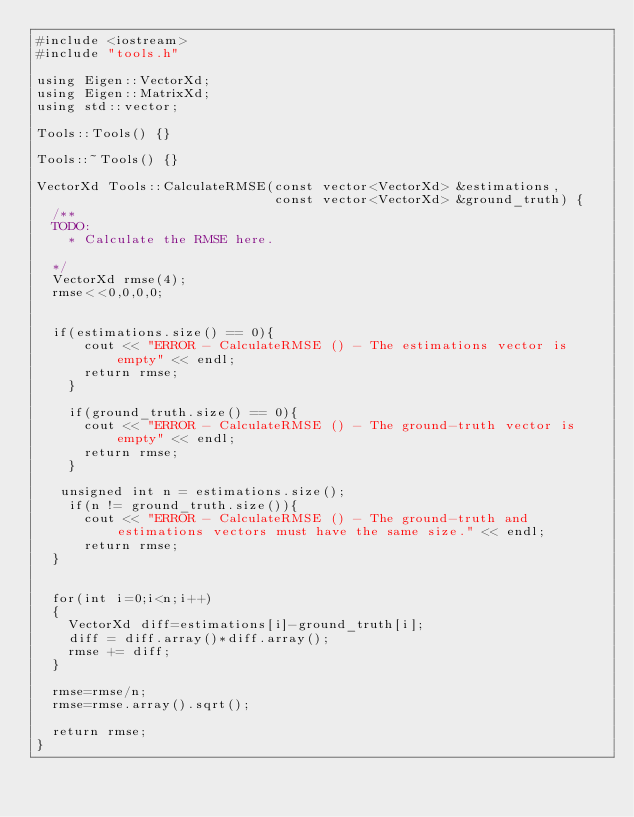<code> <loc_0><loc_0><loc_500><loc_500><_C++_>#include <iostream>
#include "tools.h"

using Eigen::VectorXd;
using Eigen::MatrixXd;
using std::vector;

Tools::Tools() {}

Tools::~Tools() {}

VectorXd Tools::CalculateRMSE(const vector<VectorXd> &estimations,
                              const vector<VectorXd> &ground_truth) {
  /**
  TODO:
    * Calculate the RMSE here.

  */
	VectorXd rmse(4);
	rmse<<0,0,0,0;


	if(estimations.size() == 0){
	    cout << "ERROR - CalculateRMSE () - The estimations vector is empty" << endl;
	    return rmse;
	  }

	  if(ground_truth.size() == 0){
	    cout << "ERROR - CalculateRMSE () - The ground-truth vector is empty" << endl;
	    return rmse;
	  }

	 unsigned int n = estimations.size();
	  if(n != ground_truth.size()){
	    cout << "ERROR - CalculateRMSE () - The ground-truth and estimations vectors must have the same size." << endl;
	    return rmse;
	}
	

	for(int i=0;i<n;i++)
	{
		VectorXd diff=estimations[i]-ground_truth[i];
		diff = diff.array()*diff.array();
		rmse += diff;
	}

	rmse=rmse/n;
	rmse=rmse.array().sqrt();

	return rmse;
}</code> 